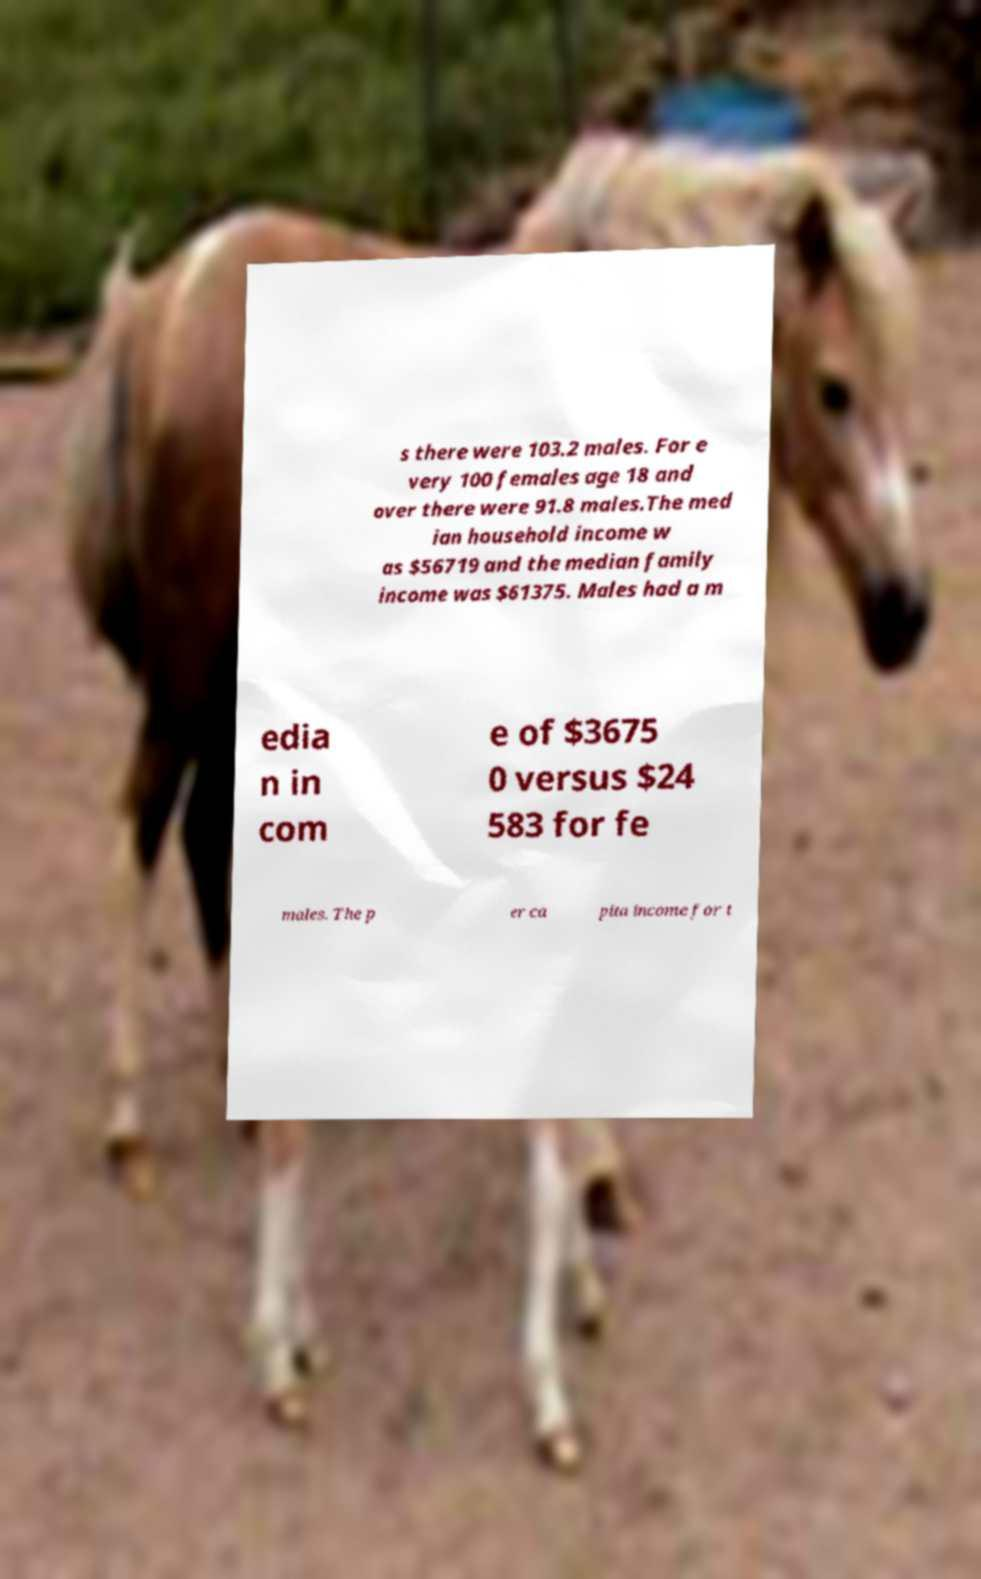What messages or text are displayed in this image? I need them in a readable, typed format. s there were 103.2 males. For e very 100 females age 18 and over there were 91.8 males.The med ian household income w as $56719 and the median family income was $61375. Males had a m edia n in com e of $3675 0 versus $24 583 for fe males. The p er ca pita income for t 